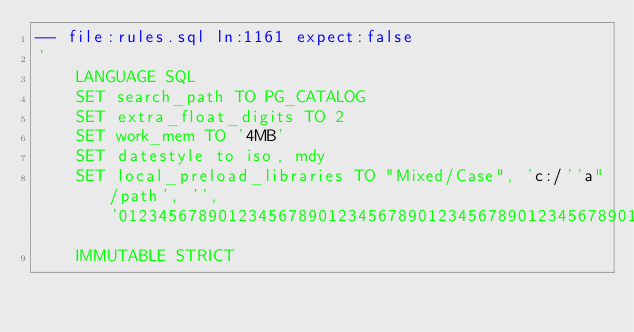Convert code to text. <code><loc_0><loc_0><loc_500><loc_500><_SQL_>-- file:rules.sql ln:1161 expect:false
'
    LANGUAGE SQL
    SET search_path TO PG_CATALOG
    SET extra_float_digits TO 2
    SET work_mem TO '4MB'
    SET datestyle to iso, mdy
    SET local_preload_libraries TO "Mixed/Case", 'c:/''a"/path', '', '0123456789012345678901234567890123456789012345678901234567890123456789012345678901234567890123456789'
    IMMUTABLE STRICT
</code> 